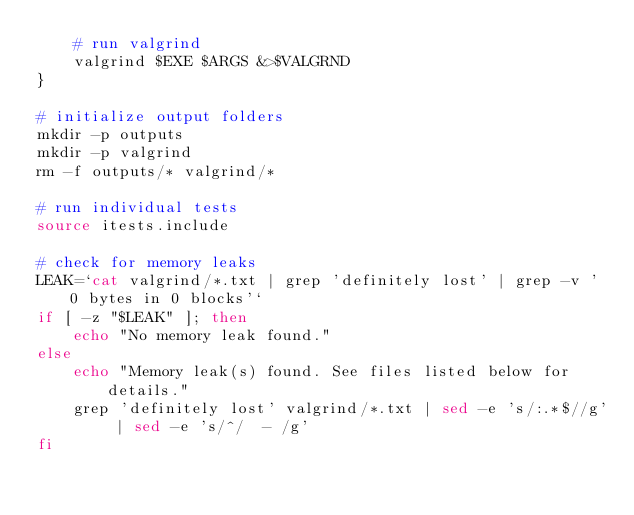<code> <loc_0><loc_0><loc_500><loc_500><_Bash_>    # run valgrind
    valgrind $EXE $ARGS &>$VALGRND
}

# initialize output folders
mkdir -p outputs
mkdir -p valgrind
rm -f outputs/* valgrind/*

# run individual tests
source itests.include

# check for memory leaks
LEAK=`cat valgrind/*.txt | grep 'definitely lost' | grep -v ' 0 bytes in 0 blocks'`
if [ -z "$LEAK" ]; then
    echo "No memory leak found."
else
    echo "Memory leak(s) found. See files listed below for details."
    grep 'definitely lost' valgrind/*.txt | sed -e 's/:.*$//g' | sed -e 's/^/  - /g'
fi

</code> 